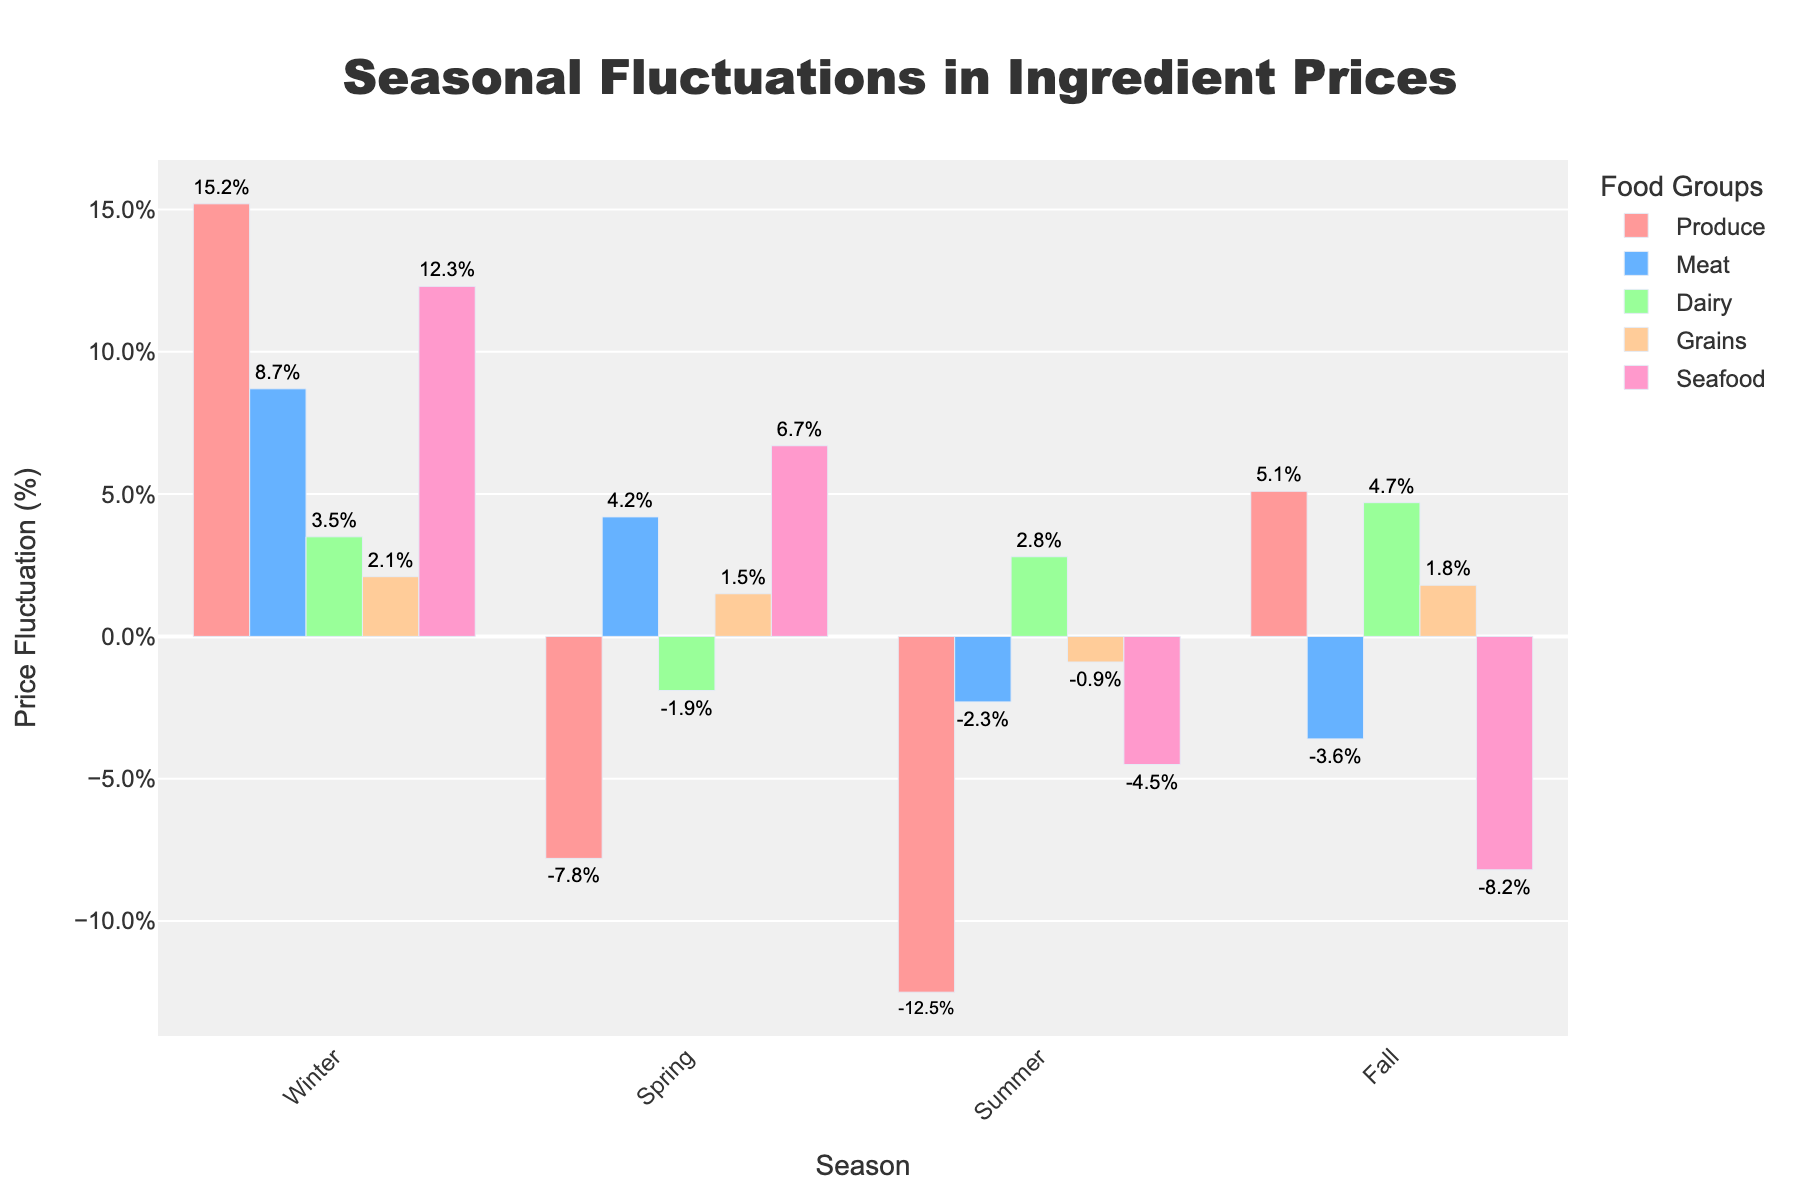Which season shows the highest price fluctuation for Produce? By examining the height of the bars for Produce across all seasons, the Winter season shows the highest fluctuation with a bar height of 15.2%.
Answer: Winter How do the price fluctuations for Meat compare between Winter and Fall? The bar for Meat in Winter is at 8.7% and in Fall is at -3.6%. Winter is 12.3% higher compared to Fall.
Answer: Winter is 12.3% higher What is the total fluctuation in Dairy prices across all seasons? Summing up the Dairy values: 3.5% (Winter) - 1.9% (Spring) + 2.8% (Summer) + 4.7% (Fall) = 9.1%.
Answer: 9.1% Which food group has the least fluctuation in Summer? By inspecting the bars for Summer, Grains has the least fluctuation with a value of -0.9%.
Answer: Grains Which food group experiences a positive fluctuation in all seasons? By examining each food group across the seasons, only Dairy has positive fluctuations in Winter, Summer, and Fall.
Answer: Dairy What is the difference in Seafood price fluctuations between Spring and Fall? Seafood in Spring is 6.7% and in Fall is -8.2%. The difference is 6.7% - (-8.2%) = 14.9%.
Answer: 14.9% How does the fluctuation of Produce in Summer compare to Spring? Produce in Spring is -7.8% and in Summer is -12.5%. Summer has a 4.7% greater decrease than Spring.
Answer: Summer is 4.7% lower In which season do Grains experience the highest fluctuation? Checking the height of the bars for Grains, Winter has the highest fluctuation at 2.1%.
Answer: Winter 